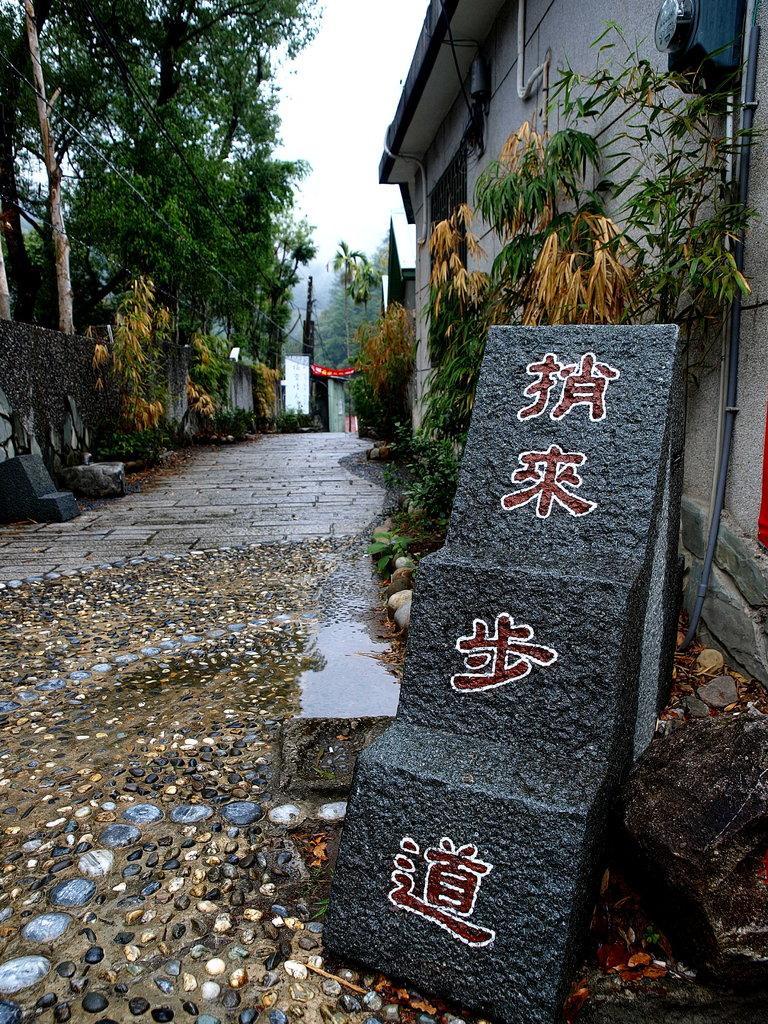How would you summarize this image in a sentence or two? On the right side of the image we can see a rock and one solid structure with some text on it. In the center of the image we can see the stones. In the background, we can see the sky, buildings, trees and a few other objects. 